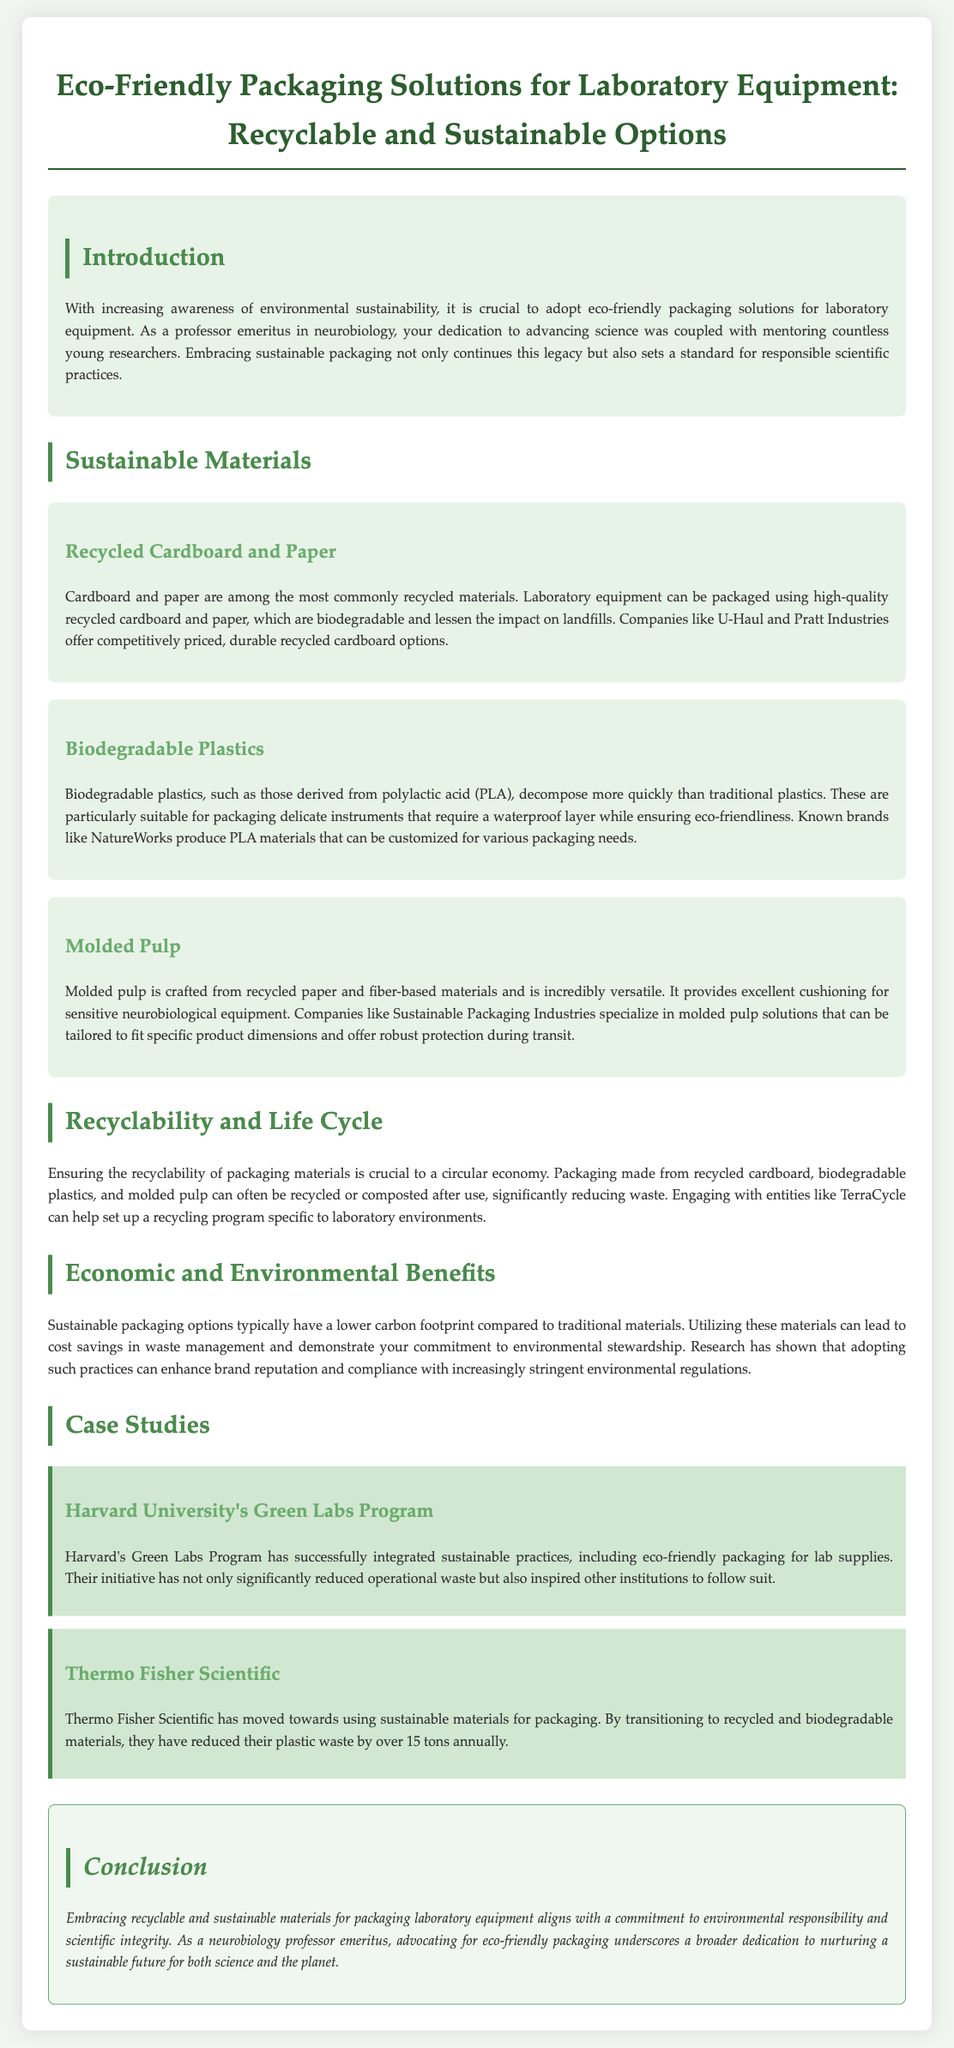What is the title of the document? The title is provided at the beginning of the document, summarizing the content.
Answer: Eco-Friendly Packaging Solutions for Laboratory Equipment: Recyclable and Sustainable Options What material is used for biodegradable plastics? The document specifies the source of biodegradable plastics used in packaging.
Answer: Polylactic acid (PLA) Which company offers recycled cardboard options? The document lists companies providing sustainable materials for packaging.
Answer: U-Haul What is the focus of Harvard University's Green Labs Program? The case study describes a significant aspect of the program's initiative.
Answer: Sustainable practices and eco-friendly packaging What is one economic benefit of sustainable packaging mentioned? The document summarizes the advantages of using eco-friendly packaging solutions.
Answer: Lower carbon footprint 